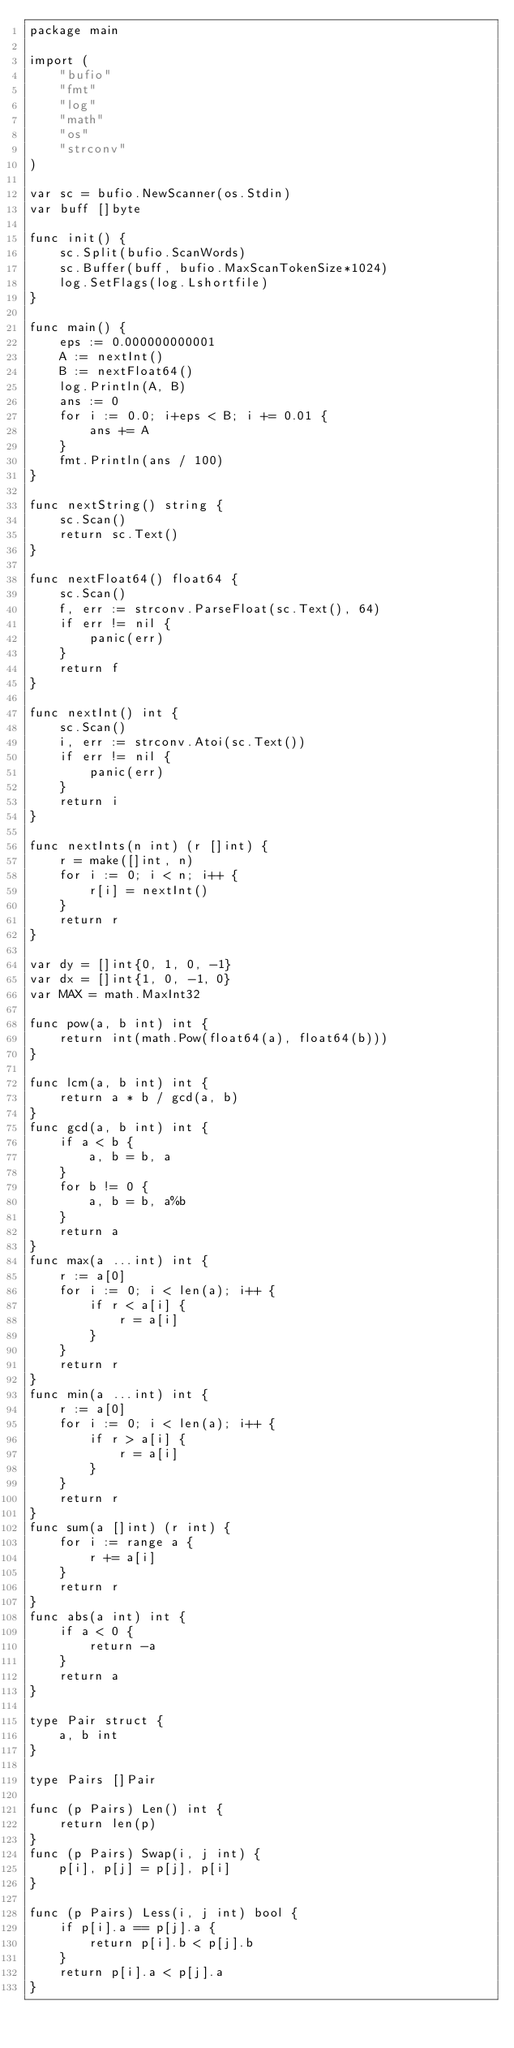Convert code to text. <code><loc_0><loc_0><loc_500><loc_500><_Go_>package main

import (
	"bufio"
	"fmt"
	"log"
	"math"
	"os"
	"strconv"
)

var sc = bufio.NewScanner(os.Stdin)
var buff []byte

func init() {
	sc.Split(bufio.ScanWords)
	sc.Buffer(buff, bufio.MaxScanTokenSize*1024)
	log.SetFlags(log.Lshortfile)
}

func main() {
	eps := 0.000000000001
	A := nextInt()
	B := nextFloat64()
	log.Println(A, B)
	ans := 0
	for i := 0.0; i+eps < B; i += 0.01 {
		ans += A
	}
	fmt.Println(ans / 100)
}

func nextString() string {
	sc.Scan()
	return sc.Text()
}

func nextFloat64() float64 {
	sc.Scan()
	f, err := strconv.ParseFloat(sc.Text(), 64)
	if err != nil {
		panic(err)
	}
	return f
}

func nextInt() int {
	sc.Scan()
	i, err := strconv.Atoi(sc.Text())
	if err != nil {
		panic(err)
	}
	return i
}

func nextInts(n int) (r []int) {
	r = make([]int, n)
	for i := 0; i < n; i++ {
		r[i] = nextInt()
	}
	return r
}

var dy = []int{0, 1, 0, -1}
var dx = []int{1, 0, -1, 0}
var MAX = math.MaxInt32

func pow(a, b int) int {
	return int(math.Pow(float64(a), float64(b)))
}

func lcm(a, b int) int {
	return a * b / gcd(a, b)
}
func gcd(a, b int) int {
	if a < b {
		a, b = b, a
	}
	for b != 0 {
		a, b = b, a%b
	}
	return a
}
func max(a ...int) int {
	r := a[0]
	for i := 0; i < len(a); i++ {
		if r < a[i] {
			r = a[i]
		}
	}
	return r
}
func min(a ...int) int {
	r := a[0]
	for i := 0; i < len(a); i++ {
		if r > a[i] {
			r = a[i]
		}
	}
	return r
}
func sum(a []int) (r int) {
	for i := range a {
		r += a[i]
	}
	return r
}
func abs(a int) int {
	if a < 0 {
		return -a
	}
	return a
}

type Pair struct {
	a, b int
}

type Pairs []Pair

func (p Pairs) Len() int {
	return len(p)
}
func (p Pairs) Swap(i, j int) {
	p[i], p[j] = p[j], p[i]
}

func (p Pairs) Less(i, j int) bool {
	if p[i].a == p[j].a {
		return p[i].b < p[j].b
	}
	return p[i].a < p[j].a
}
</code> 